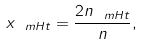Convert formula to latex. <formula><loc_0><loc_0><loc_500><loc_500>x _ { \ m H t } = \frac { 2 n _ { \ m H t } } { n } ,</formula> 